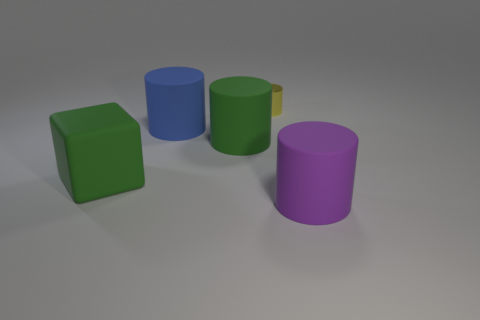Subtract all large purple rubber cylinders. How many cylinders are left? 3 Add 1 blue cylinders. How many objects exist? 6 Subtract all blue cylinders. How many cylinders are left? 3 Subtract all blocks. How many objects are left? 4 Subtract all blue cylinders. Subtract all blue blocks. How many cylinders are left? 3 Subtract all blue spheres. How many cyan cubes are left? 0 Subtract all tiny yellow things. Subtract all shiny objects. How many objects are left? 3 Add 1 large purple objects. How many large purple objects are left? 2 Add 3 yellow things. How many yellow things exist? 4 Subtract 0 cyan spheres. How many objects are left? 5 